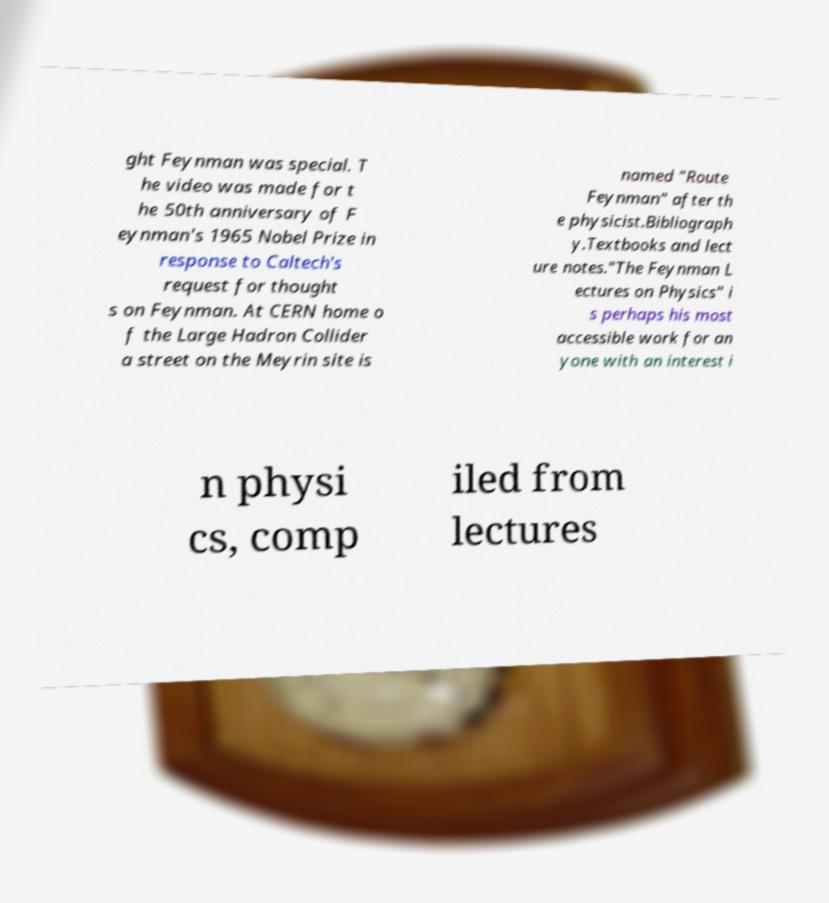Please read and relay the text visible in this image. What does it say? ght Feynman was special. T he video was made for t he 50th anniversary of F eynman's 1965 Nobel Prize in response to Caltech's request for thought s on Feynman. At CERN home o f the Large Hadron Collider a street on the Meyrin site is named "Route Feynman" after th e physicist.Bibliograph y.Textbooks and lect ure notes."The Feynman L ectures on Physics" i s perhaps his most accessible work for an yone with an interest i n physi cs, comp iled from lectures 